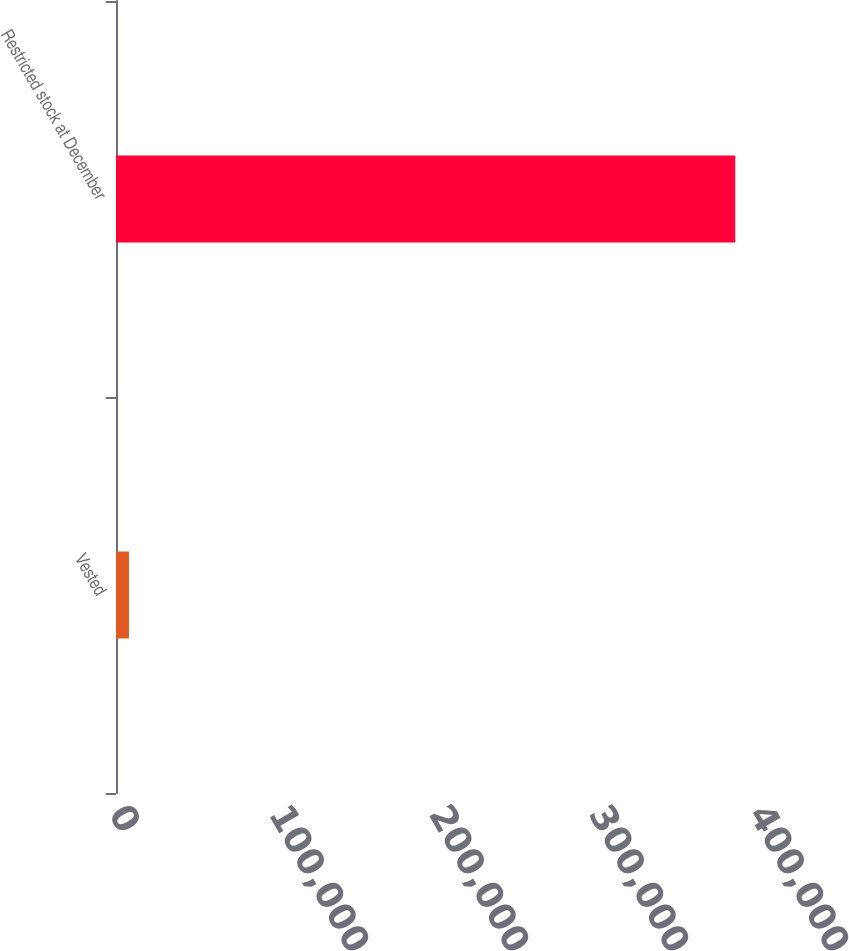Convert chart to OTSL. <chart><loc_0><loc_0><loc_500><loc_500><bar_chart><fcel>Vested<fcel>Restricted stock at December<nl><fcel>8100<fcel>387030<nl></chart> 